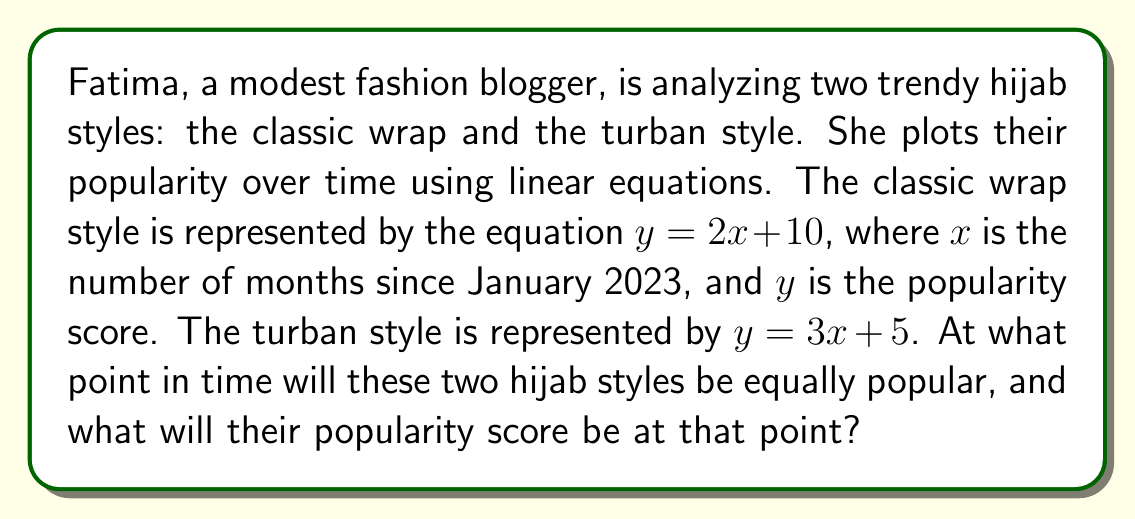Teach me how to tackle this problem. To find the intersection point of these two trend lines, we need to solve the system of linear equations:

$$\begin{cases}
y = 2x + 10 \\
y = 3x + 5
\end{cases}$$

At the intersection point, both equations will have the same $x$ and $y$ values. So, we can set them equal to each other:

$$2x + 10 = 3x + 5$$

Now, let's solve for $x$:

$$2x + 10 = 3x + 5$$
$$10 - 5 = 3x - 2x$$
$$5 = x$$

So, the intersection occurs when $x = 5$, which represents 5 months after January 2023 (i.e., June 2023).

To find the $y$ value (popularity score) at this point, we can substitute $x = 5$ into either of the original equations. Let's use the first one:

$$y = 2(5) + 10 = 10 + 10 = 20$$

Therefore, the popularity score at the intersection point is 20.
Answer: The two hijab styles will be equally popular 5 months after January 2023 (in June 2023), with a popularity score of 20. 